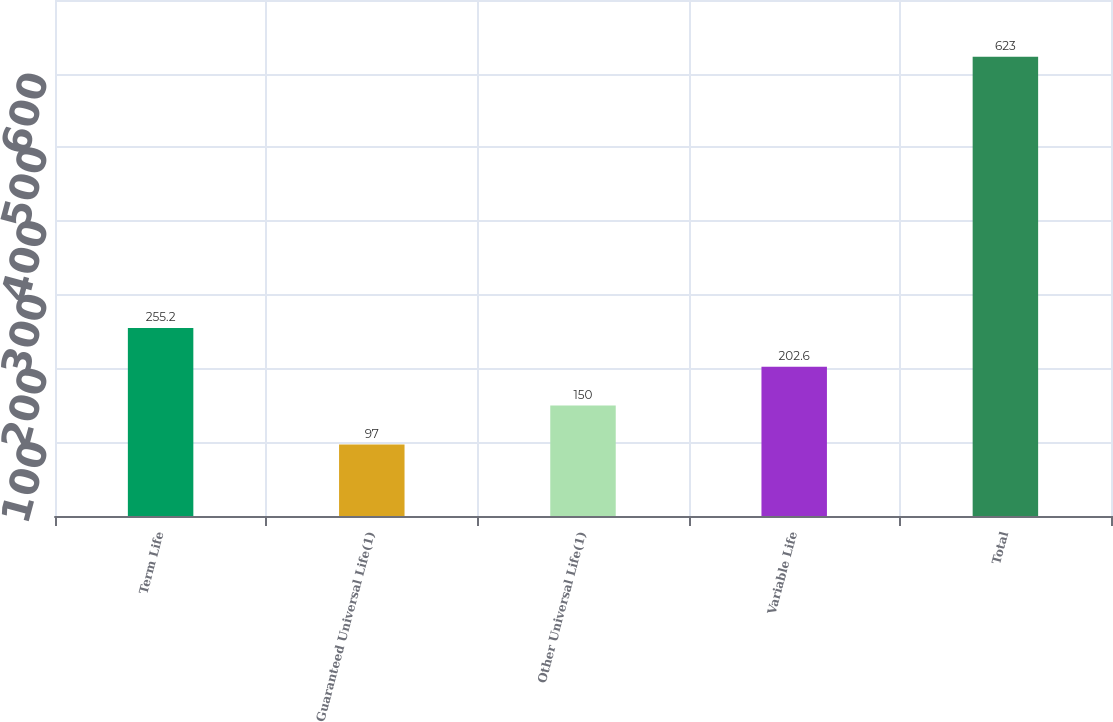Convert chart. <chart><loc_0><loc_0><loc_500><loc_500><bar_chart><fcel>Term Life<fcel>Guaranteed Universal Life(1)<fcel>Other Universal Life(1)<fcel>Variable Life<fcel>Total<nl><fcel>255.2<fcel>97<fcel>150<fcel>202.6<fcel>623<nl></chart> 